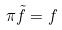Convert formula to latex. <formula><loc_0><loc_0><loc_500><loc_500>\pi \tilde { f } = f</formula> 